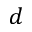<formula> <loc_0><loc_0><loc_500><loc_500>d</formula> 